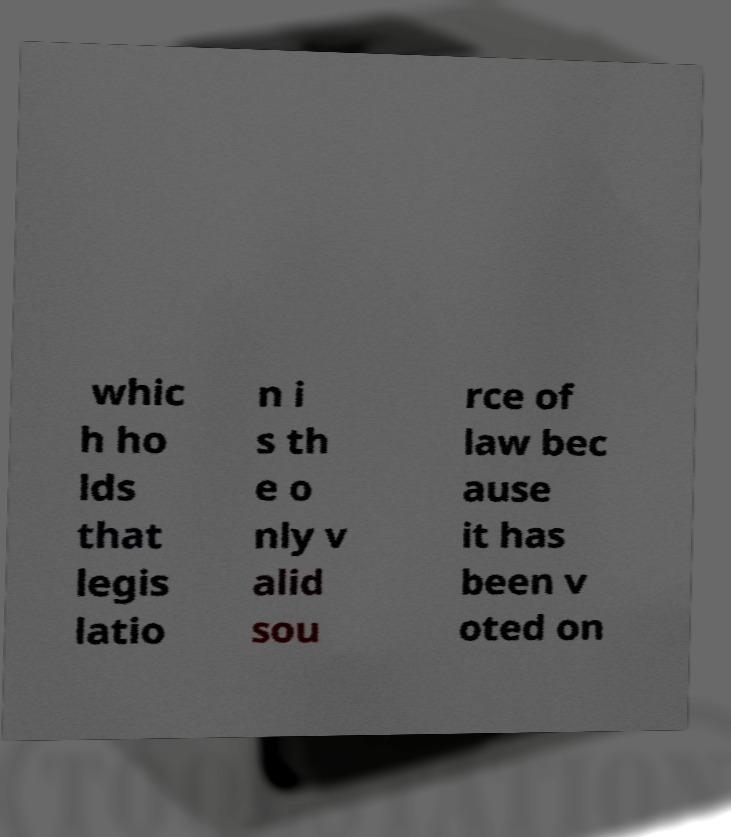I need the written content from this picture converted into text. Can you do that? whic h ho lds that legis latio n i s th e o nly v alid sou rce of law bec ause it has been v oted on 